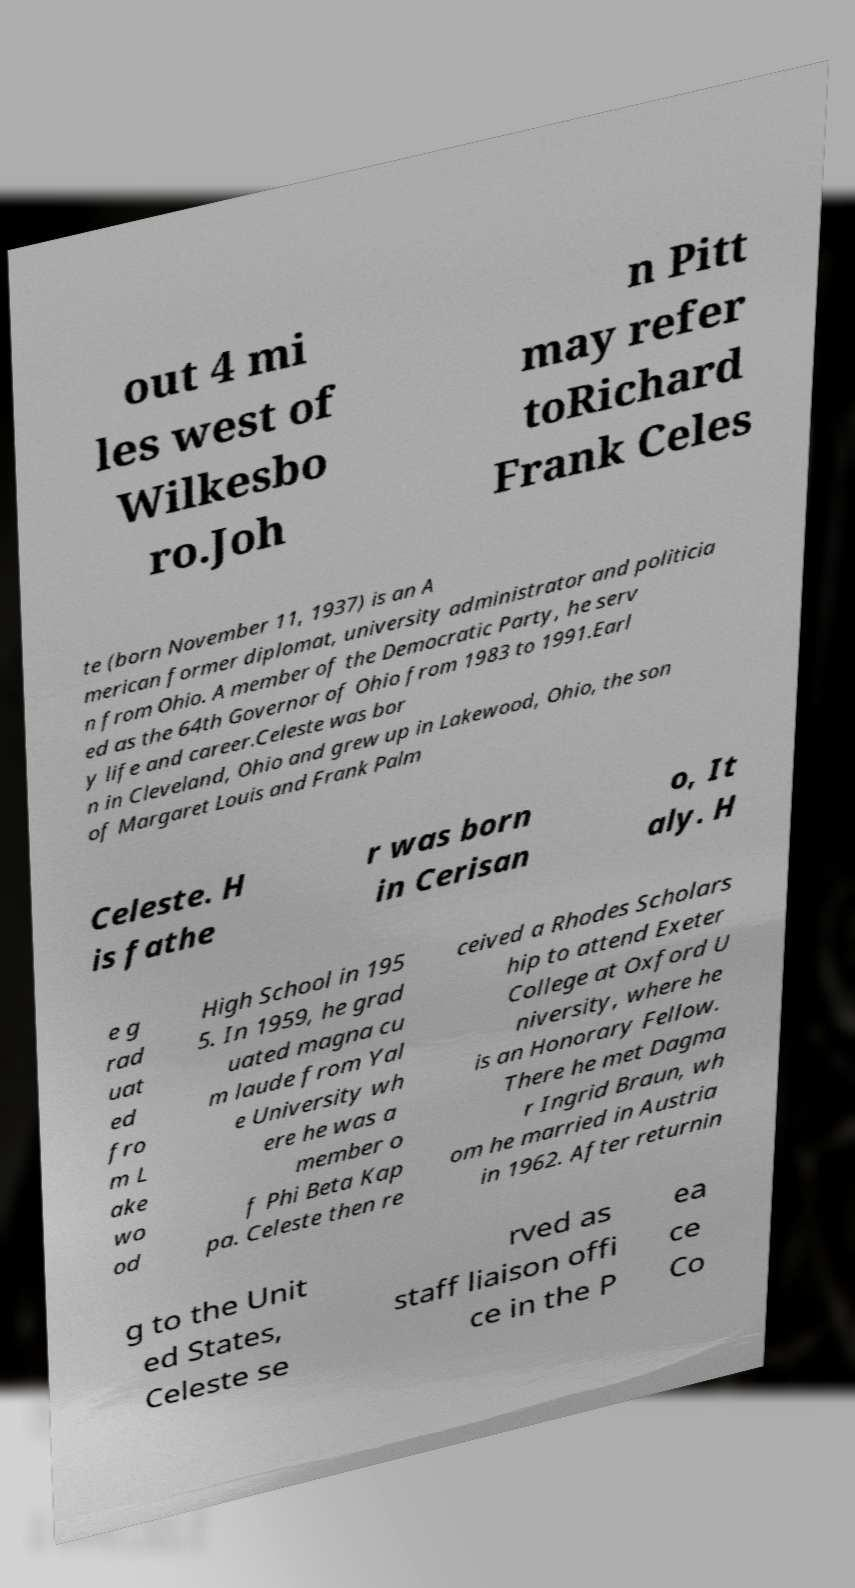Can you accurately transcribe the text from the provided image for me? out 4 mi les west of Wilkesbo ro.Joh n Pitt may refer toRichard Frank Celes te (born November 11, 1937) is an A merican former diplomat, university administrator and politicia n from Ohio. A member of the Democratic Party, he serv ed as the 64th Governor of Ohio from 1983 to 1991.Earl y life and career.Celeste was bor n in Cleveland, Ohio and grew up in Lakewood, Ohio, the son of Margaret Louis and Frank Palm Celeste. H is fathe r was born in Cerisan o, It aly. H e g rad uat ed fro m L ake wo od High School in 195 5. In 1959, he grad uated magna cu m laude from Yal e University wh ere he was a member o f Phi Beta Kap pa. Celeste then re ceived a Rhodes Scholars hip to attend Exeter College at Oxford U niversity, where he is an Honorary Fellow. There he met Dagma r Ingrid Braun, wh om he married in Austria in 1962. After returnin g to the Unit ed States, Celeste se rved as staff liaison offi ce in the P ea ce Co 